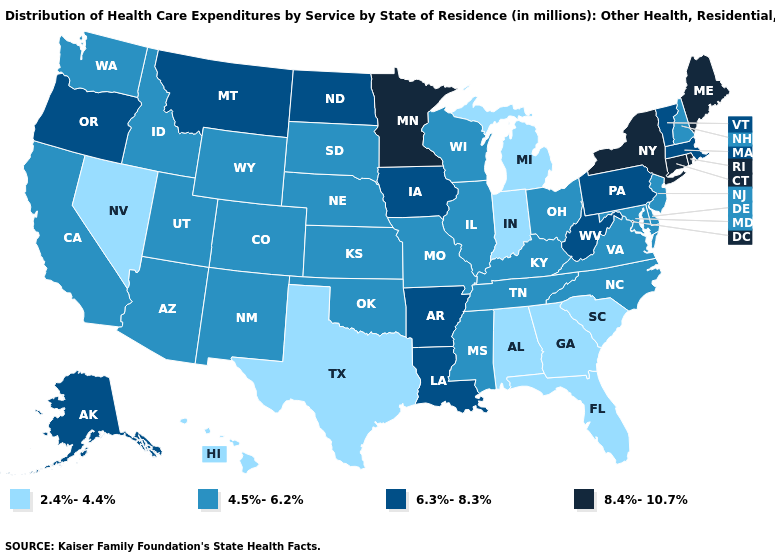Does Idaho have a higher value than Louisiana?
Short answer required. No. Among the states that border Louisiana , does Mississippi have the lowest value?
Give a very brief answer. No. Name the states that have a value in the range 6.3%-8.3%?
Give a very brief answer. Alaska, Arkansas, Iowa, Louisiana, Massachusetts, Montana, North Dakota, Oregon, Pennsylvania, Vermont, West Virginia. Does the map have missing data?
Quick response, please. No. Does Missouri have a lower value than Michigan?
Write a very short answer. No. What is the value of New York?
Quick response, please. 8.4%-10.7%. Which states have the lowest value in the MidWest?
Short answer required. Indiana, Michigan. What is the lowest value in the MidWest?
Concise answer only. 2.4%-4.4%. Among the states that border Illinois , does Iowa have the highest value?
Give a very brief answer. Yes. Name the states that have a value in the range 6.3%-8.3%?
Be succinct. Alaska, Arkansas, Iowa, Louisiana, Massachusetts, Montana, North Dakota, Oregon, Pennsylvania, Vermont, West Virginia. Among the states that border New Hampshire , does Maine have the lowest value?
Keep it brief. No. Among the states that border Wyoming , does Montana have the lowest value?
Answer briefly. No. How many symbols are there in the legend?
Give a very brief answer. 4. Does Virginia have the same value as Nebraska?
Quick response, please. Yes. Name the states that have a value in the range 6.3%-8.3%?
Answer briefly. Alaska, Arkansas, Iowa, Louisiana, Massachusetts, Montana, North Dakota, Oregon, Pennsylvania, Vermont, West Virginia. 